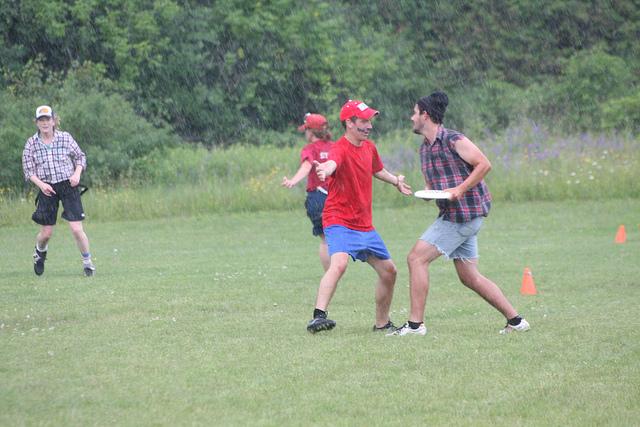What game are they playing?
Concise answer only. Frisbee. How many cones can you see?
Write a very short answer. 2. How many red hats are there?
Write a very short answer. 2. 